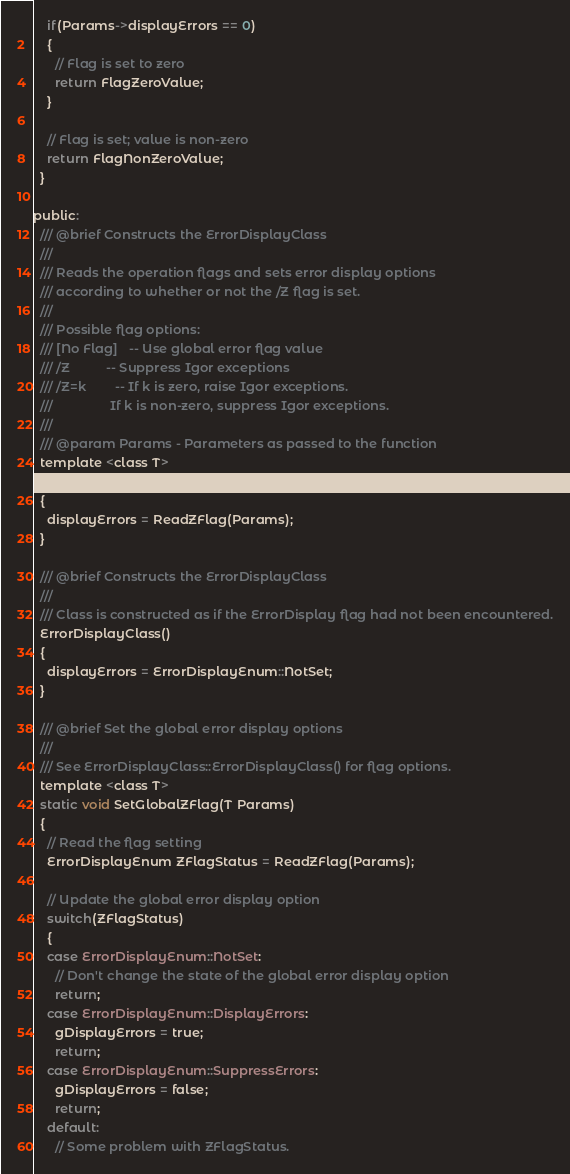<code> <loc_0><loc_0><loc_500><loc_500><_C_>    if(Params->displayErrors == 0)
    {
      // Flag is set to zero
      return FlagZeroValue;
    }

    // Flag is set; value is non-zero
    return FlagNonZeroValue;
  }

public:
  /// @brief Constructs the ErrorDisplayClass
  ///
  /// Reads the operation flags and sets error display options
  /// according to whether or not the /Z flag is set.
  ///
  /// Possible flag options:
  /// [No Flag]	-- Use global error flag value
  /// /Z			-- Suppress Igor exceptions
  /// /Z=k		-- If k is zero, raise Igor exceptions.
  ///				   If k is non-zero, suppress Igor exceptions.
  ///
  /// @param Params - Parameters as passed to the function
  template <class T>
  ErrorDisplayClass(T Params)
  {
    displayErrors = ReadZFlag(Params);
  }

  /// @brief Constructs the ErrorDisplayClass
  ///
  /// Class is constructed as if the ErrorDisplay flag had not been encountered.
  ErrorDisplayClass()
  {
    displayErrors = ErrorDisplayEnum::NotSet;
  }

  /// @brief Set the global error display options
  ///
  /// See ErrorDisplayClass::ErrorDisplayClass() for flag options.
  template <class T>
  static void SetGlobalZFlag(T Params)
  {
    // Read the flag setting
    ErrorDisplayEnum ZFlagStatus = ReadZFlag(Params);

    // Update the global error display option
    switch(ZFlagStatus)
    {
    case ErrorDisplayEnum::NotSet:
      // Don't change the state of the global error display option
      return;
    case ErrorDisplayEnum::DisplayErrors:
      gDisplayErrors = true;
      return;
    case ErrorDisplayEnum::SuppressErrors:
      gDisplayErrors = false;
      return;
    default:
      // Some problem with ZFlagStatus.</code> 